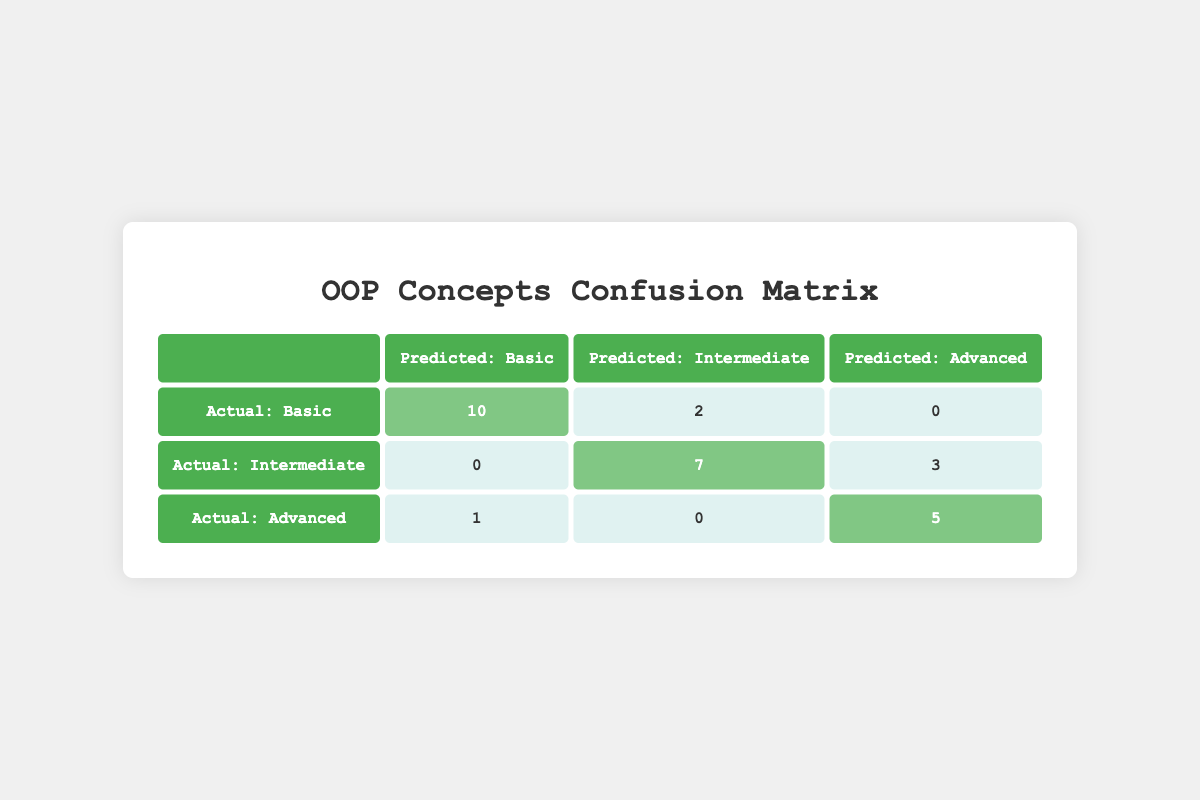What is the predicted count for "Basic Concepts" when the true label is also "Basic Concepts"? The table indicates that when the true label is "Basic Concepts", the predicted count is highlighted as 10 in the corresponding cell of the matrix.
Answer: 10 How many instances were incorrectly classified as "Intermediate Concepts" when the true label is "Basic Concepts"? In the row for "Actual: Basic", there is a count of 2 under "Predicted: Intermediate Concepts". This is the number of instances that were incorrectly classified.
Answer: 2 Is there any instance where "Advanced Concepts" was incorrectly predicted as "Basic Concepts"? The table shows a count of 1 in the row for "Actual: Advanced" and the column for "Predicted: Basic Concepts", indicating that there was indeed one instance where "Advanced Concepts" was incorrectly classified.
Answer: Yes What is the total number of instances for "Intermediate Concepts"? To find the total, we add the predicted counts for "Intermediate Concepts": 0 (Basic), 7 (Intermediate), and 3 (Advanced) which equals 10.
Answer: 10 How many total instances were correctly classified across all categories? For correct classifications, we look at the diagonal counts: 10 (Basic), 7 (Intermediate), and 5 (Advanced). Adding these together gives 10 + 7 + 5 = 22.
Answer: 22 How many total instances were classified as "Advanced Concepts" across all true labels? In the first row (Basic) the count is 0, in the second row (Intermediate) the count is 3, and in the third row (Advanced) the count is 5. Adding these gives 0 + 3 + 5 = 8.
Answer: 8 What is the percentage of correctly classified "Advanced Concepts"? The total number of "Advanced Concepts" instances is 6 (1 incorrectly classified to Basic + 5 correctly classified to Advanced) and the correct ones are 5. The percentage is (5/6) * 100 which is approximately 83.33%.
Answer: 83.33% Which concepts were more challenging to classify based on the table? By looking for the highest counts in the off-diagonal cells, we see that 2 were incorrectly classified as Intermediate from Basic and 3 were incorrectly classified as Advanced from Intermediate. This indicates that Classifying Intermediate Concepts is more challenging than Basic.
Answer: Intermediate Concepts 